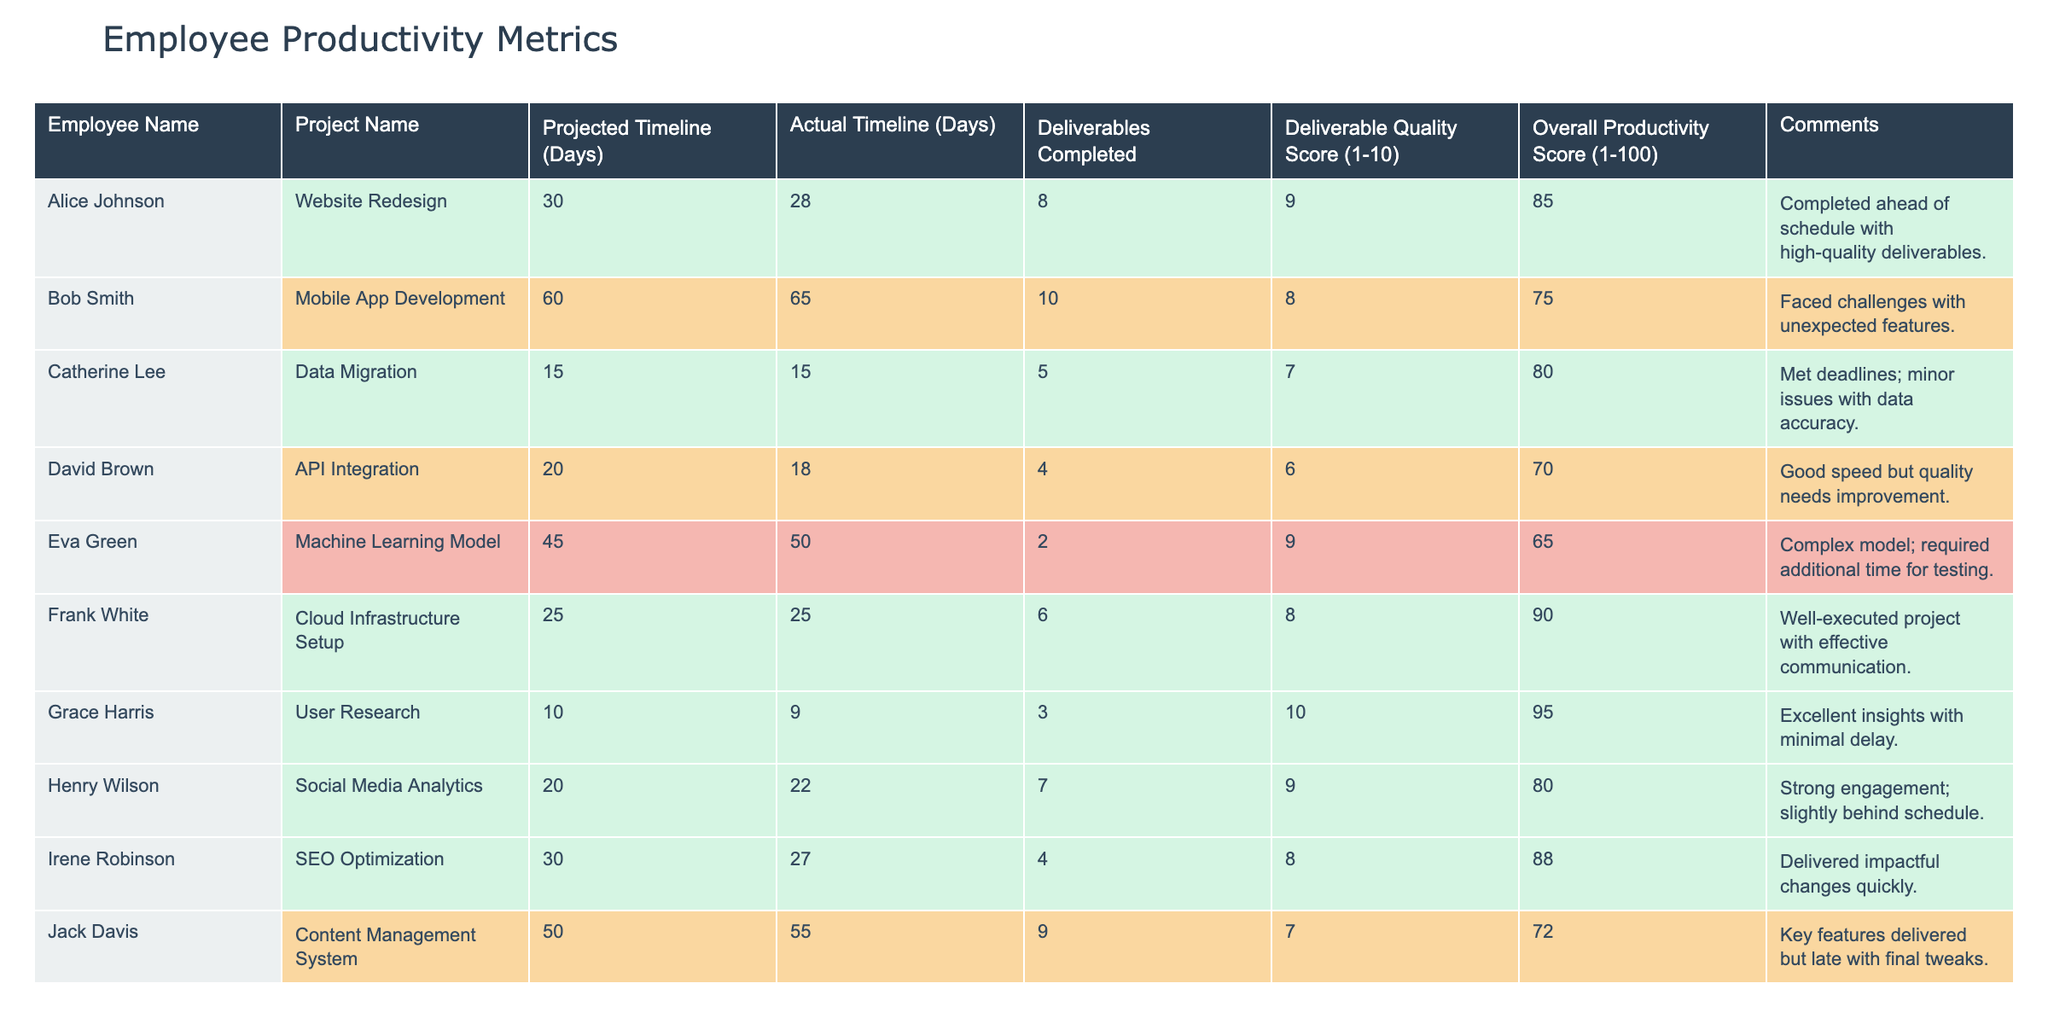What is the Overall Productivity Score for Alice Johnson? The table shows that Alice Johnson has an Overall Productivity Score of 85.
Answer: 85 Which employee completed their project ahead of schedule? Looking at the "Projected Timeline" and "Actual Timeline" for each employee, Alice Johnson completed her project in 28 days against a projection of 30 days, indicating she was ahead of schedule.
Answer: Alice Johnson What is the average Overall Productivity Score for the employees? To calculate the average, sum the Overall Productivity Scores (85 + 75 + 80 + 70 + 65 + 90 + 95 + 80 + 88 + 72 = 810) and divide by the number of employees (10), giving 810 / 10 = 81.
Answer: 81 Did Frank White receive the highest Deliverable Quality Score? By comparing all Deliverable Quality Scores, Frank White scored 8, which is not the highest since Grace Harris scored 10.
Answer: No Which employee had the lowest number of deliverables completed? The table indicates that Eva Green completed only 2 deliverables, which is the lowest compared to the others.
Answer: Eva Green How many employees have an Overall Productivity Score of 80 or above? By counting the scores from the table, there are six employees (Alice Johnson, Catherine Lee, Frank White, Grace Harris, Irene Robinson, and Henry Wilson) with scores of 80 or above.
Answer: 6 What is the difference between the Projected and Actual timeline for Bob Smith? Bob Smith had a Projected Timeline of 60 days and an Actual Timeline of 65 days, which means the difference is 65 - 60 = 5 days.
Answer: 5 days Which employee had a Quality Score of 10? The table shows that Grace Harris received a Deliverable Quality Score of 10.
Answer: Grace Harris If we only consider employees with Overall Productivity Scores below 80, who had the highest Deliverable Quality Score? Among the employees with scores below 80, David Brown (6) and Eva Green (9) had the highest Deliverable Quality Scores of 6 and 9 respectively, making Eva Green the highest scorer in that group.
Answer: Eva Green What percentage of the projects were completed on or ahead of schedule? The projects completed on or ahead of schedule are those of Alice Johnson, Frank White, Grace Harris, and Irene Robinson. Out of 10 total projects, that makes 4, leading to a percentage of (4 / 10) * 100 = 40%.
Answer: 40% 